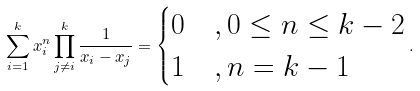<formula> <loc_0><loc_0><loc_500><loc_500>\sum _ { i = 1 } ^ { k } x _ { i } ^ { n } \prod _ { j \ne i } ^ { k } \frac { 1 } { x _ { i } - x _ { j } } = \begin{cases} 0 & , 0 \leq n \leq k - 2 \\ 1 & , n = k - 1 \end{cases} .</formula> 